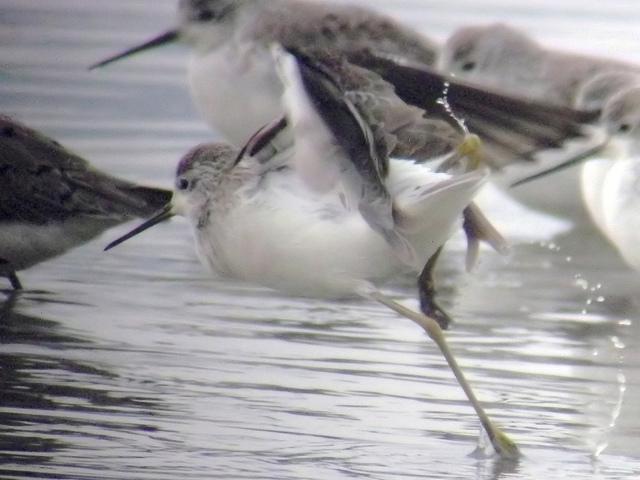How many birds are in the photo?
Give a very brief answer. 6. 